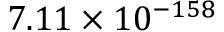<formula> <loc_0><loc_0><loc_500><loc_500>7 . 1 1 \times 1 0 ^ { - 1 5 8 }</formula> 